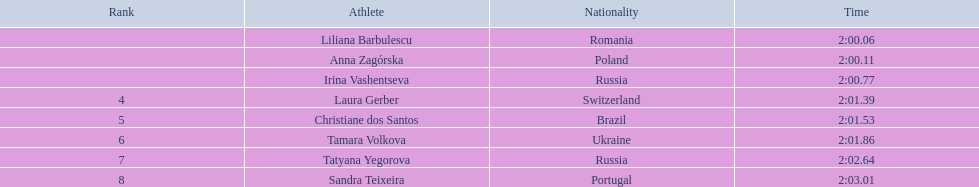Who are all the participants in the athletic event? Liliana Barbulescu, Anna Zagórska, Irina Vashentseva, Laura Gerber, Christiane dos Santos, Tamara Volkova, Tatyana Yegorova, Sandra Teixeira. What were their respective timings in the heat? 2:00.06, 2:00.11, 2:00.77, 2:01.39, 2:01.53, 2:01.86, 2:02.64, 2:03.01. Among these timings, which one is the fastest? 2:00.06. Which athlete achieved this fastest time? Liliana Barbulescu. 